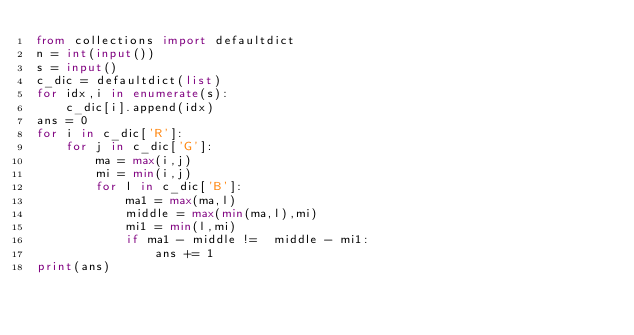Convert code to text. <code><loc_0><loc_0><loc_500><loc_500><_Python_>from collections import defaultdict
n = int(input())
s = input()
c_dic = defaultdict(list)
for idx,i in enumerate(s):
    c_dic[i].append(idx)
ans = 0
for i in c_dic['R']:
    for j in c_dic['G']:
        ma = max(i,j)
        mi = min(i,j)
        for l in c_dic['B']:
            ma1 = max(ma,l)
            middle = max(min(ma,l),mi)
            mi1 = min(l,mi)
            if ma1 - middle !=  middle - mi1:
                ans += 1
print(ans)</code> 